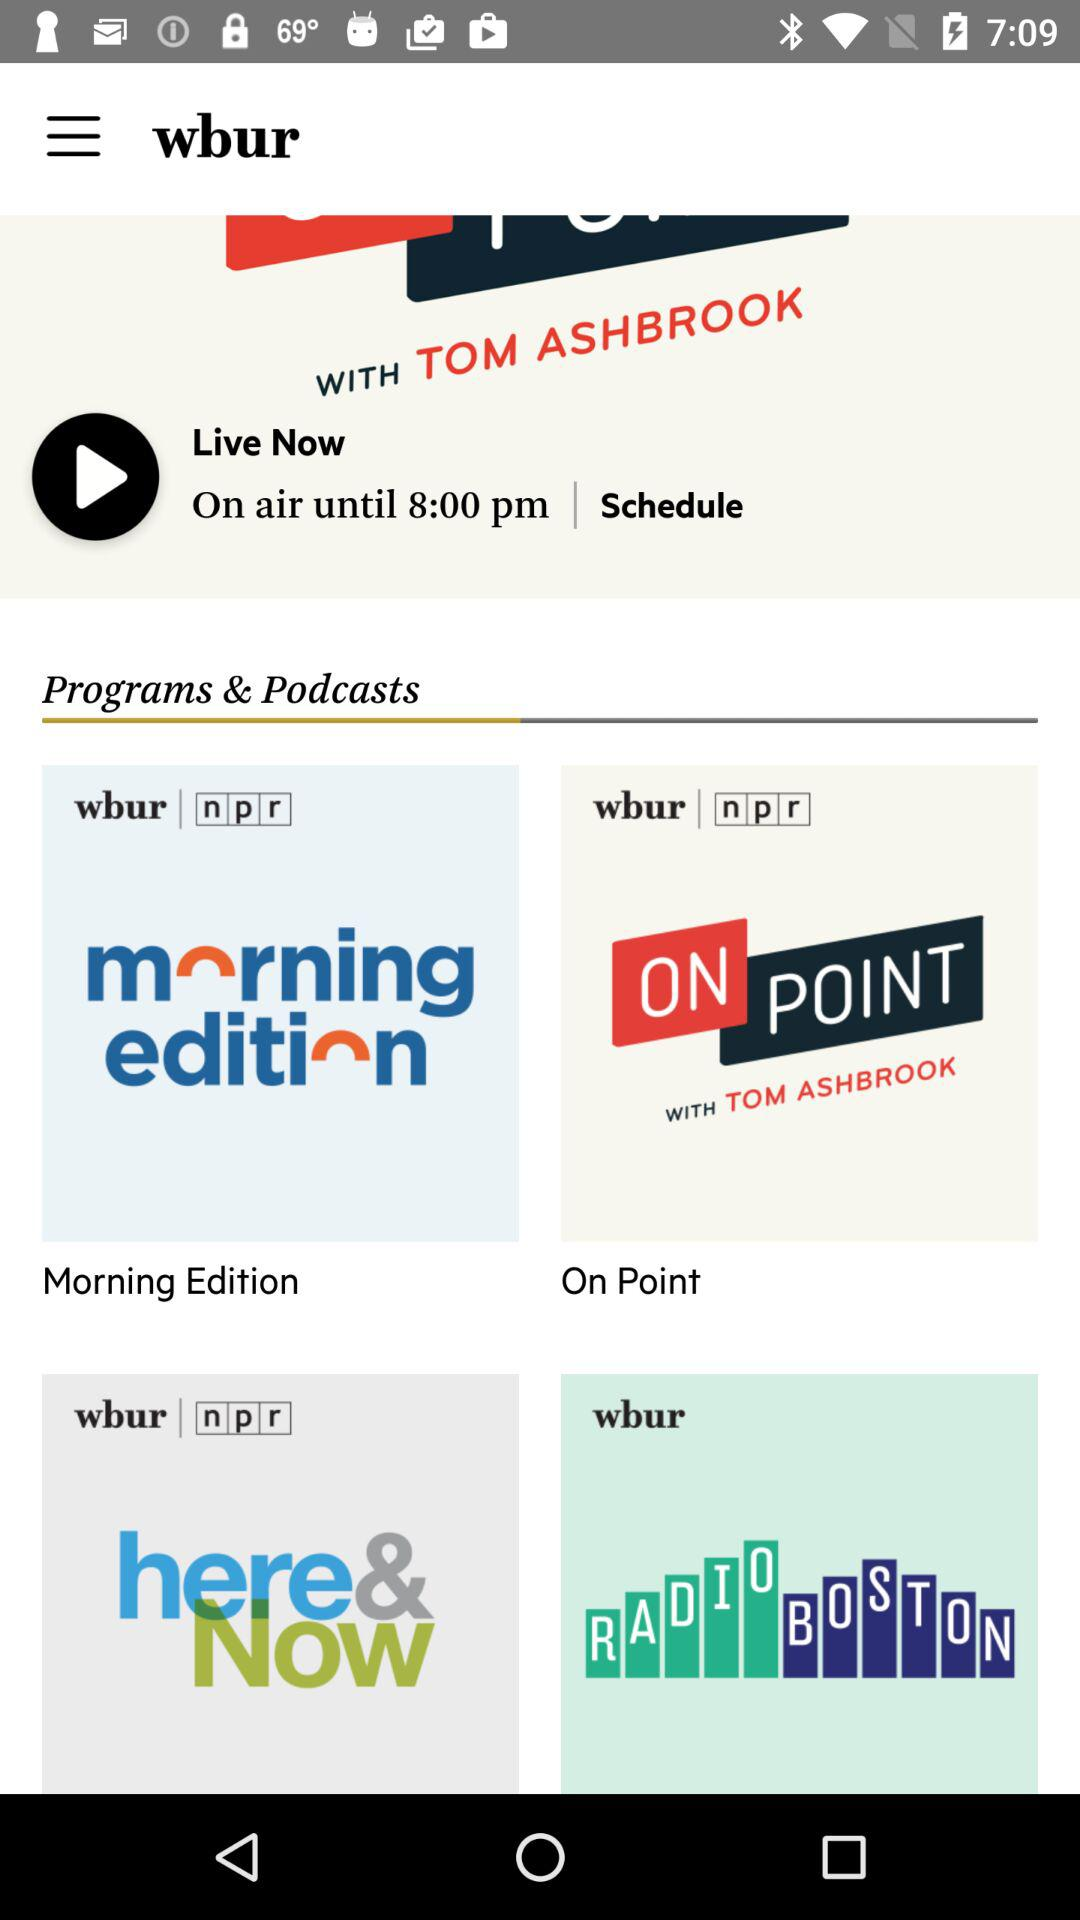What is the app name? The app name is "wbur". 